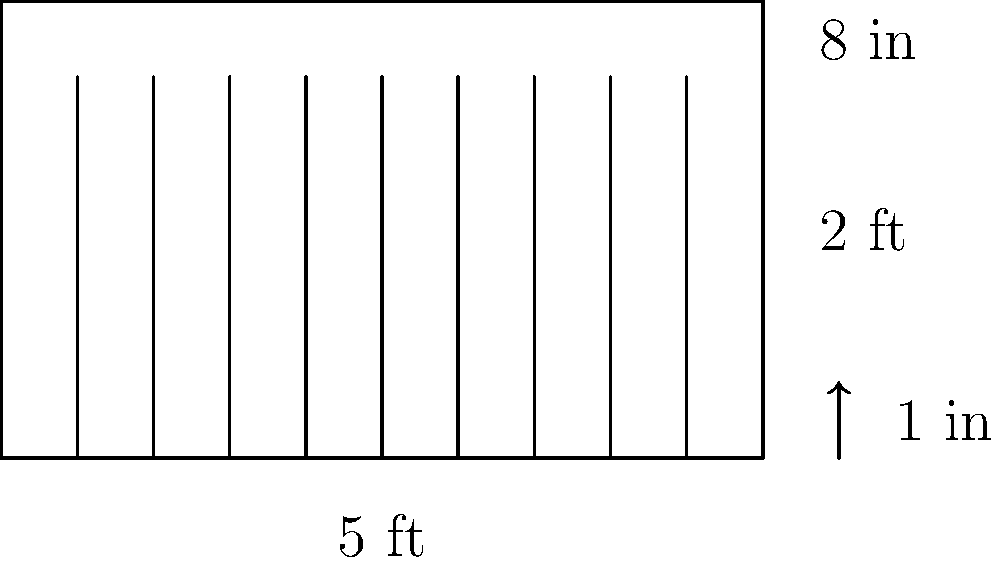As a book editor, you're organizing your personal library. You have a shelf that's 5 feet long, 2 feet deep, and 8 inches high. If each book is 1 inch thick, how many books can you fit on this shelf in a single row? To solve this problem, we need to follow these steps:

1. Convert the shelf length from feet to inches:
   $5 \text{ feet} = 5 \times 12 = 60 \text{ inches}$

2. Determine how many 1-inch thick books can fit in 60 inches:
   $\text{Number of books} = \frac{\text{Shelf length}}{\text{Book thickness}}$
   $\text{Number of books} = \frac{60 \text{ inches}}{1 \text{ inch/book}} = 60 \text{ books}$

3. Check if the height of the shelf is sufficient:
   The shelf is 8 inches high, which is typically enough for standard books.

4. Consider any practical constraints:
   In reality, you might want to leave a small amount of space for ease of removing books, but for this calculation, we'll assume a perfect fit.

Therefore, you can fit 60 books on this shelf in a single row.
Answer: 60 books 